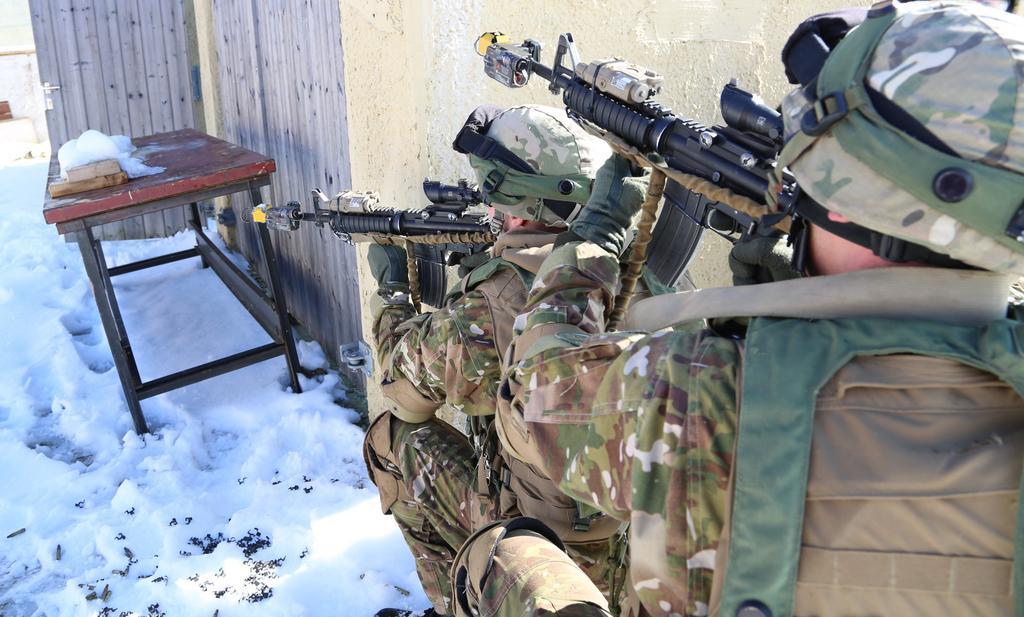Can you describe this image briefly? There is a snow on the ground and table on it. At one corner there are soldiers holding guns in front of wall. There is a door attached to the wall. 